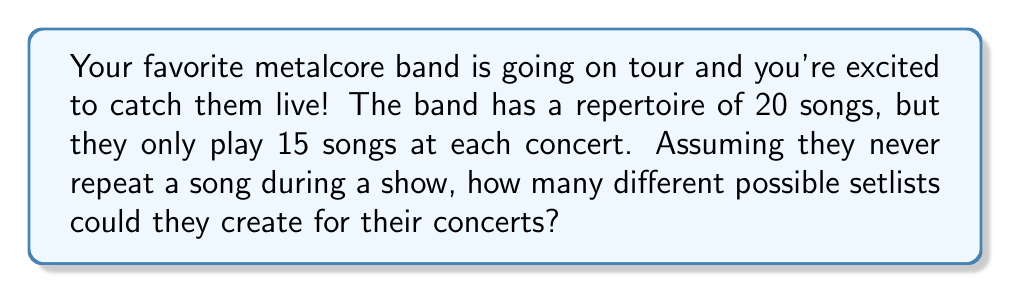Help me with this question. Let's approach this step-by-step:

1) This is a combination problem. We're selecting 15 songs out of 20, where the order matters (as it's a setlist).

2) The formula for permutations without repetition is:

   $$P(n,r) = \frac{n!}{(n-r)!}$$

   Where $n$ is the total number of items to choose from, and $r$ is the number of items being chosen.

3) In this case, $n = 20$ (total songs) and $r = 15$ (songs in the setlist).

4) Plugging these numbers into our formula:

   $$P(20,15) = \frac{20!}{(20-15)!} = \frac{20!}{5!}$$

5) Expanding this:
   
   $$\frac{20 * 19 * 18 * 17 * 16 * 15!}{5 * 4 * 3 * 2 * 1}$$

6) The 15! cancels out in the numerator and denominator, leaving us with:

   $$20 * 19 * 18 * 17 * 16 = 1,860,480$$

Therefore, there are 1,860,480 possible different setlists for the concert.
Answer: 1,860,480 